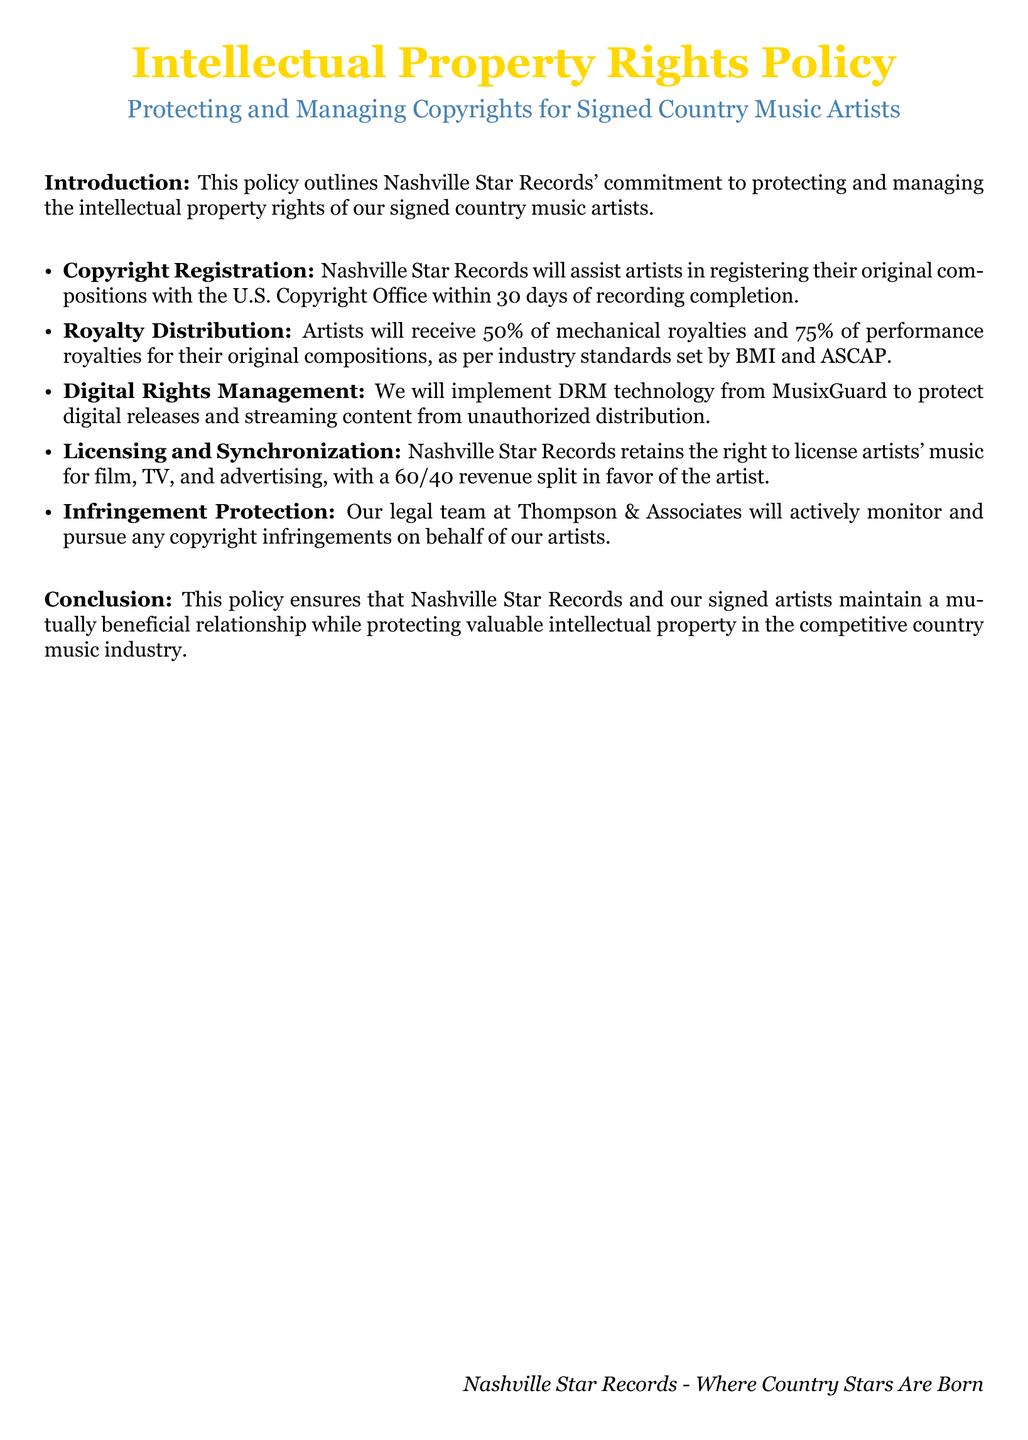What is the main focus of the policy? The main focus of the policy is to outline Nashville Star Records' commitment to protecting and managing the intellectual property rights of artists.
Answer: Protecting and managing intellectual property rights How much of the mechanical royalties do artists receive? The document states that artists will receive 50% of mechanical royalties according to industry standards.
Answer: 50% What technology will be used for digital rights management? The document mentions that MusixGuard will be used to protect digital releases.
Answer: MusixGuard What is the revenue split for licensing and synchronization? The policy specifies a 60/40 revenue split in favor of the artist for licensing and synchronization deals.
Answer: 60/40 Who will assist artists in copyright registration? The document states that Nashville Star Records will assist artists in registering their original compositions.
Answer: Nashville Star Records What percentage of performance royalties do artists receive? According to the policy, artists are entitled to 75% of performance royalties for their original compositions.
Answer: 75% Which legal team is mentioned for infringement protection? The document refers to Thompson & Associates as the legal team monitoring copyright infringements.
Answer: Thompson & Associates What is the deadline for copyright registration after recording completion? The policy clearly states that artists should register their works within 30 days of recording completion.
Answer: 30 days 